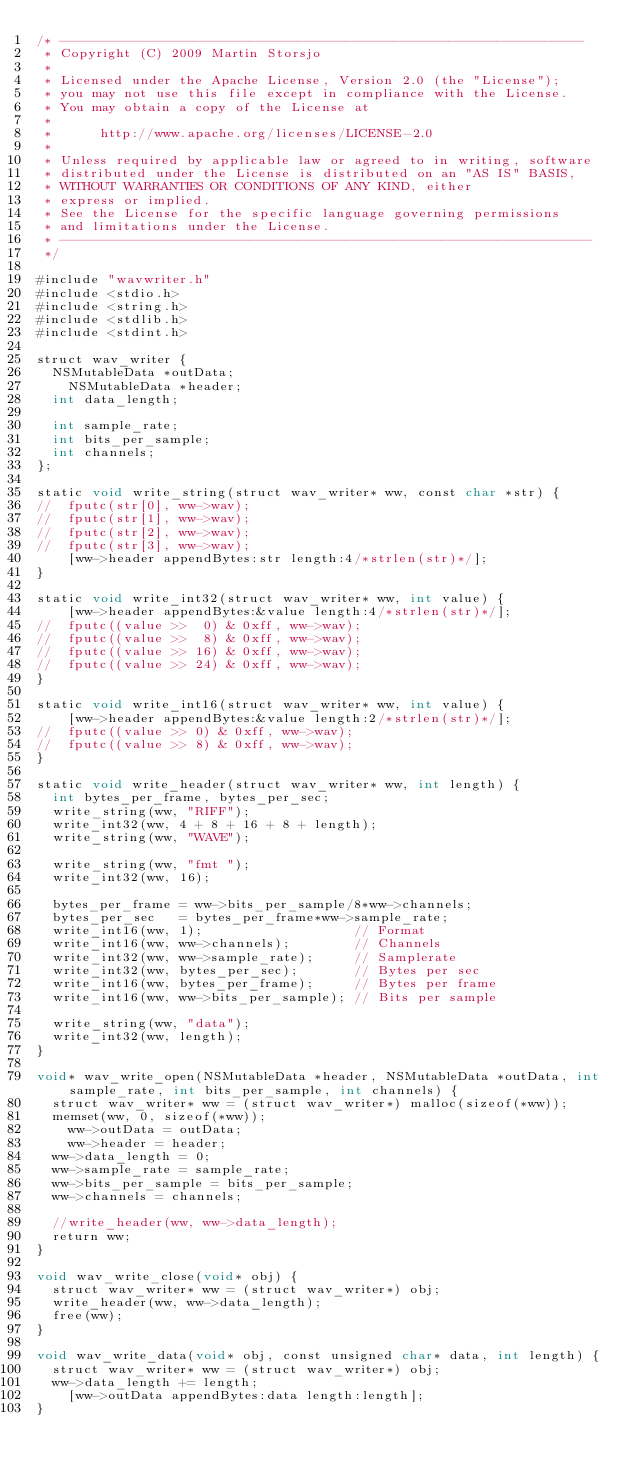Convert code to text. <code><loc_0><loc_0><loc_500><loc_500><_ObjectiveC_>/* ------------------------------------------------------------------
 * Copyright (C) 2009 Martin Storsjo
 *
 * Licensed under the Apache License, Version 2.0 (the "License");
 * you may not use this file except in compliance with the License.
 * You may obtain a copy of the License at
 *
 *      http://www.apache.org/licenses/LICENSE-2.0
 *
 * Unless required by applicable law or agreed to in writing, software
 * distributed under the License is distributed on an "AS IS" BASIS,
 * WITHOUT WARRANTIES OR CONDITIONS OF ANY KIND, either
 * express or implied.
 * See the License for the specific language governing permissions
 * and limitations under the License.
 * -------------------------------------------------------------------
 */

#include "wavwriter.h"
#include <stdio.h>
#include <string.h>
#include <stdlib.h>
#include <stdint.h>

struct wav_writer {
	NSMutableData *outData;
    NSMutableData *header;
	int data_length;

	int sample_rate;
	int bits_per_sample;
	int channels;
};

static void write_string(struct wav_writer* ww, const char *str) {
//	fputc(str[0], ww->wav);
//	fputc(str[1], ww->wav);
//	fputc(str[2], ww->wav);
//	fputc(str[3], ww->wav);
    [ww->header appendBytes:str length:4/*strlen(str)*/];
}

static void write_int32(struct wav_writer* ww, int value) {
    [ww->header appendBytes:&value length:4/*strlen(str)*/];
//	fputc((value >>  0) & 0xff, ww->wav);
//	fputc((value >>  8) & 0xff, ww->wav);
//	fputc((value >> 16) & 0xff, ww->wav);
//	fputc((value >> 24) & 0xff, ww->wav);
}

static void write_int16(struct wav_writer* ww, int value) {
    [ww->header appendBytes:&value length:2/*strlen(str)*/];
//	fputc((value >> 0) & 0xff, ww->wav);
//	fputc((value >> 8) & 0xff, ww->wav);
}

static void write_header(struct wav_writer* ww, int length) {
	int bytes_per_frame, bytes_per_sec;
	write_string(ww, "RIFF");
	write_int32(ww, 4 + 8 + 16 + 8 + length);
	write_string(ww, "WAVE");

	write_string(ww, "fmt ");
	write_int32(ww, 16);

	bytes_per_frame = ww->bits_per_sample/8*ww->channels;
	bytes_per_sec   = bytes_per_frame*ww->sample_rate;
	write_int16(ww, 1);                   // Format
	write_int16(ww, ww->channels);        // Channels
	write_int32(ww, ww->sample_rate);     // Samplerate
	write_int32(ww, bytes_per_sec);       // Bytes per sec
	write_int16(ww, bytes_per_frame);     // Bytes per frame
	write_int16(ww, ww->bits_per_sample); // Bits per sample

	write_string(ww, "data");
	write_int32(ww, length);
}

void* wav_write_open(NSMutableData *header, NSMutableData *outData, int sample_rate, int bits_per_sample, int channels) {
	struct wav_writer* ww = (struct wav_writer*) malloc(sizeof(*ww));
	memset(ww, 0, sizeof(*ww));
    ww->outData = outData;
    ww->header = header;
	ww->data_length = 0;
	ww->sample_rate = sample_rate;
	ww->bits_per_sample = bits_per_sample;
	ww->channels = channels;

	//write_header(ww, ww->data_length);
	return ww;
}

void wav_write_close(void* obj) {
	struct wav_writer* ww = (struct wav_writer*) obj;
	write_header(ww, ww->data_length);
	free(ww);
}

void wav_write_data(void* obj, const unsigned char* data, int length) {
	struct wav_writer* ww = (struct wav_writer*) obj;
	ww->data_length += length;
    [ww->outData appendBytes:data length:length];
}

</code> 